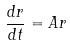Convert formula to latex. <formula><loc_0><loc_0><loc_500><loc_500>\frac { d r } { d t } = A r</formula> 